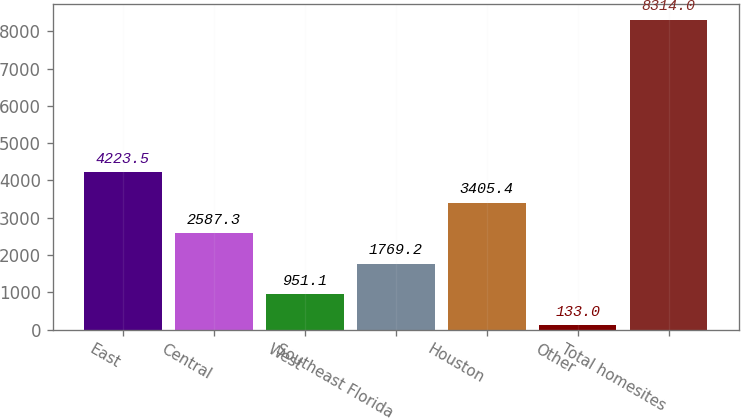Convert chart to OTSL. <chart><loc_0><loc_0><loc_500><loc_500><bar_chart><fcel>East<fcel>Central<fcel>West<fcel>Southeast Florida<fcel>Houston<fcel>Other<fcel>Total homesites<nl><fcel>4223.5<fcel>2587.3<fcel>951.1<fcel>1769.2<fcel>3405.4<fcel>133<fcel>8314<nl></chart> 